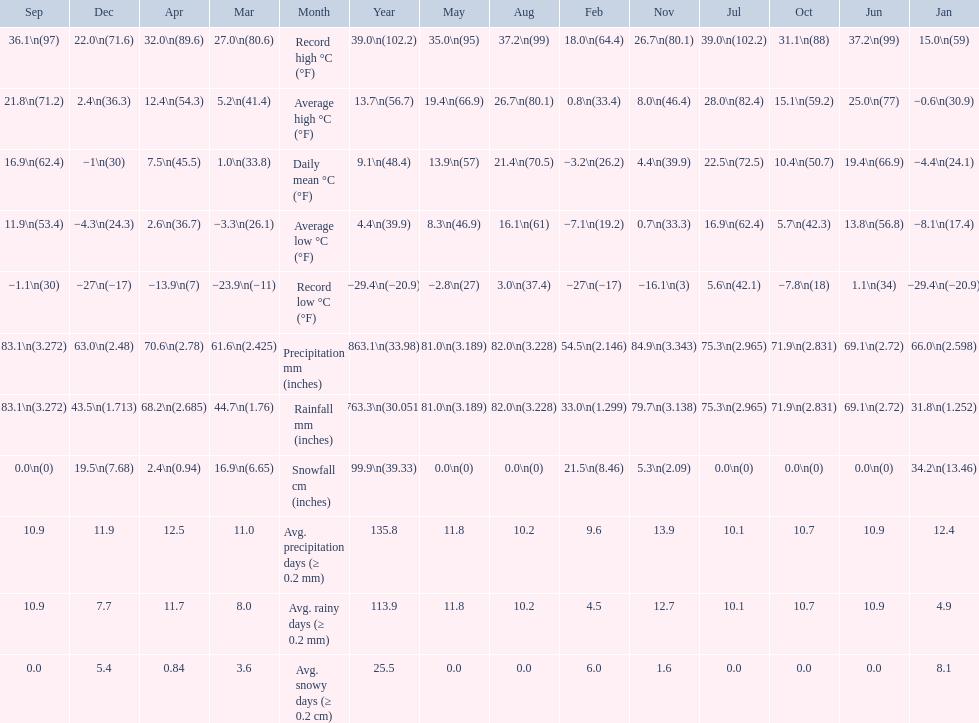Which month had an average high of 21.8 degrees and a record low of -1.1? September. 